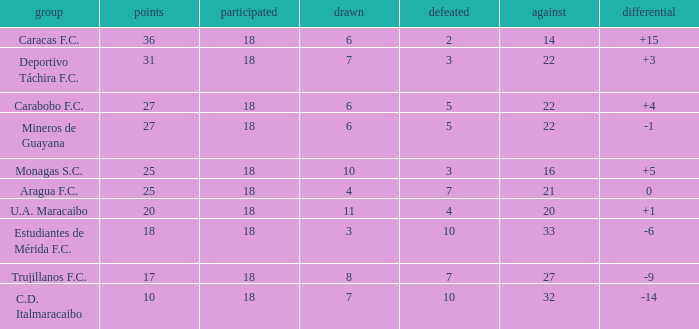What is the combined points of all teams that had against scores under 14? None. 